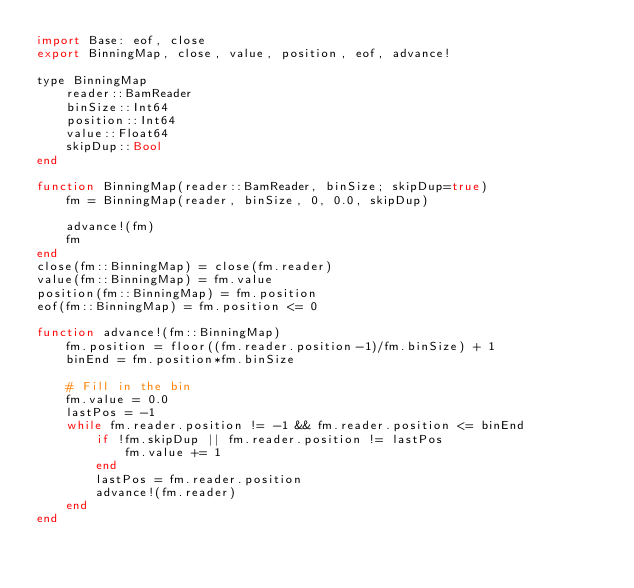Convert code to text. <code><loc_0><loc_0><loc_500><loc_500><_Julia_>import Base: eof, close
export BinningMap, close, value, position, eof, advance!

type BinningMap
    reader::BamReader
    binSize::Int64
    position::Int64
    value::Float64
    skipDup::Bool
end

function BinningMap(reader::BamReader, binSize; skipDup=true)
    fm = BinningMap(reader, binSize, 0, 0.0, skipDup)
    
    advance!(fm)
    fm
end
close(fm::BinningMap) = close(fm.reader)
value(fm::BinningMap) = fm.value
position(fm::BinningMap) = fm.position
eof(fm::BinningMap) = fm.position <= 0

function advance!(fm::BinningMap)
    fm.position = floor((fm.reader.position-1)/fm.binSize) + 1
    binEnd = fm.position*fm.binSize
    
    # Fill in the bin
    fm.value = 0.0
    lastPos = -1
    while fm.reader.position != -1 && fm.reader.position <= binEnd
        if !fm.skipDup || fm.reader.position != lastPos
            fm.value += 1
        end
        lastPos = fm.reader.position
        advance!(fm.reader)
    end
end</code> 